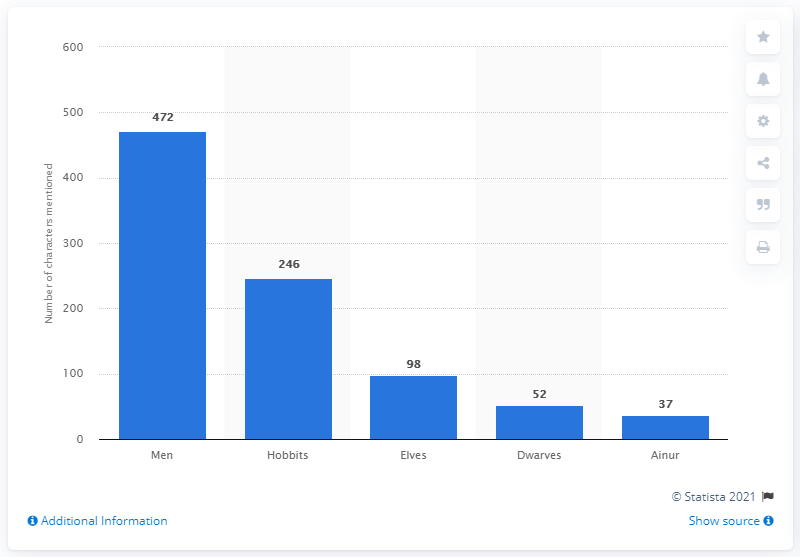Identify some key points in this picture. It is estimated that 246 hobbits reside in the land of Middle Earth. 